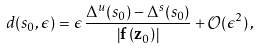<formula> <loc_0><loc_0><loc_500><loc_500>d ( s _ { 0 } , \epsilon ) = \epsilon \, \frac { \Delta ^ { u } ( s _ { 0 } ) - \Delta ^ { s } ( s _ { 0 } ) } { \left | { \mathbf f } \left ( { \mathbf z } _ { 0 } \right ) \right | } + { \mathcal { O } } ( \epsilon ^ { 2 } ) \, ,</formula> 